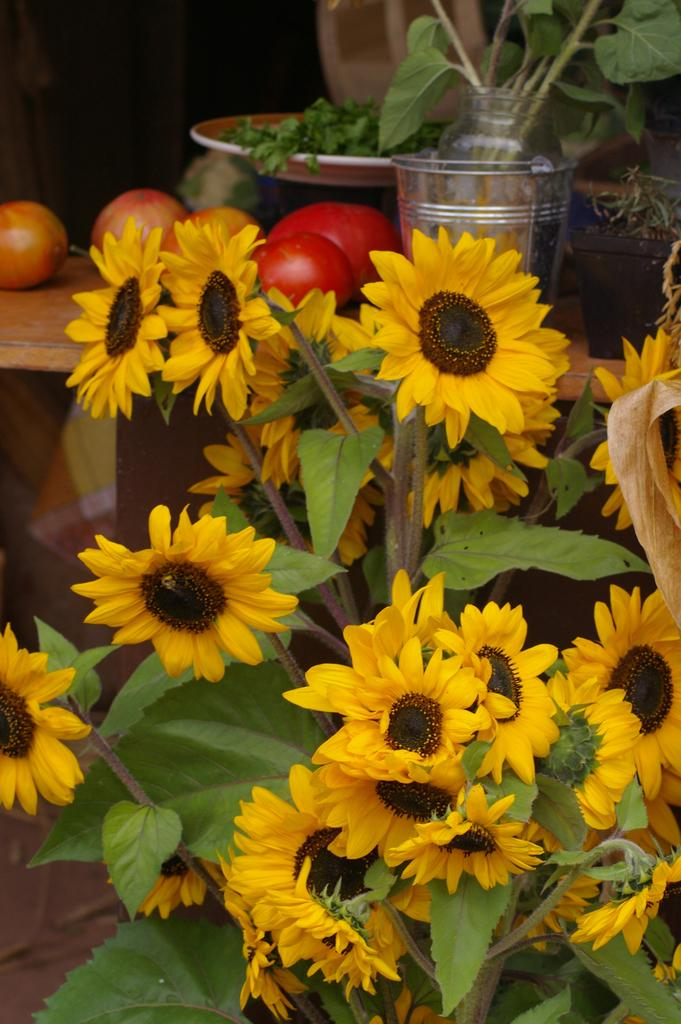What type of plants can be seen in the image? There are flowers and tomatoes in the image. What parts of the plants are visible in the image? There are leaves and vegetable leaves in the image. What is used to hold the flowers in the image? There is a vase in a bucket in the image. What is used to serve the tomatoes in the image? There is a plate in the image. What type of beast can be seen in the image? There is no beast present in the image. What type of fowl can be seen in the image? There is no fowl present in the image. 